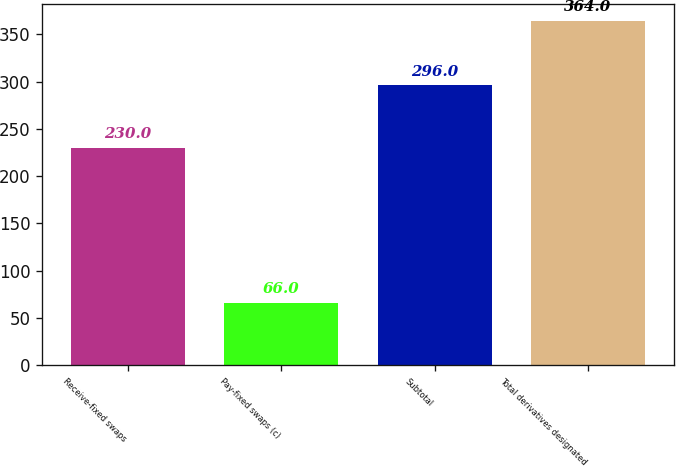Convert chart. <chart><loc_0><loc_0><loc_500><loc_500><bar_chart><fcel>Receive-fixed swaps<fcel>Pay-fixed swaps (c)<fcel>Subtotal<fcel>Total derivatives designated<nl><fcel>230<fcel>66<fcel>296<fcel>364<nl></chart> 